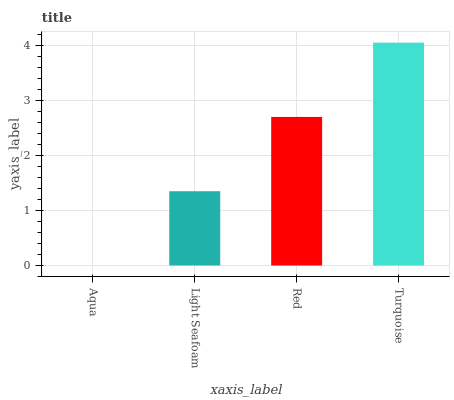Is Aqua the minimum?
Answer yes or no. Yes. Is Turquoise the maximum?
Answer yes or no. Yes. Is Light Seafoam the minimum?
Answer yes or no. No. Is Light Seafoam the maximum?
Answer yes or no. No. Is Light Seafoam greater than Aqua?
Answer yes or no. Yes. Is Aqua less than Light Seafoam?
Answer yes or no. Yes. Is Aqua greater than Light Seafoam?
Answer yes or no. No. Is Light Seafoam less than Aqua?
Answer yes or no. No. Is Red the high median?
Answer yes or no. Yes. Is Light Seafoam the low median?
Answer yes or no. Yes. Is Aqua the high median?
Answer yes or no. No. Is Red the low median?
Answer yes or no. No. 